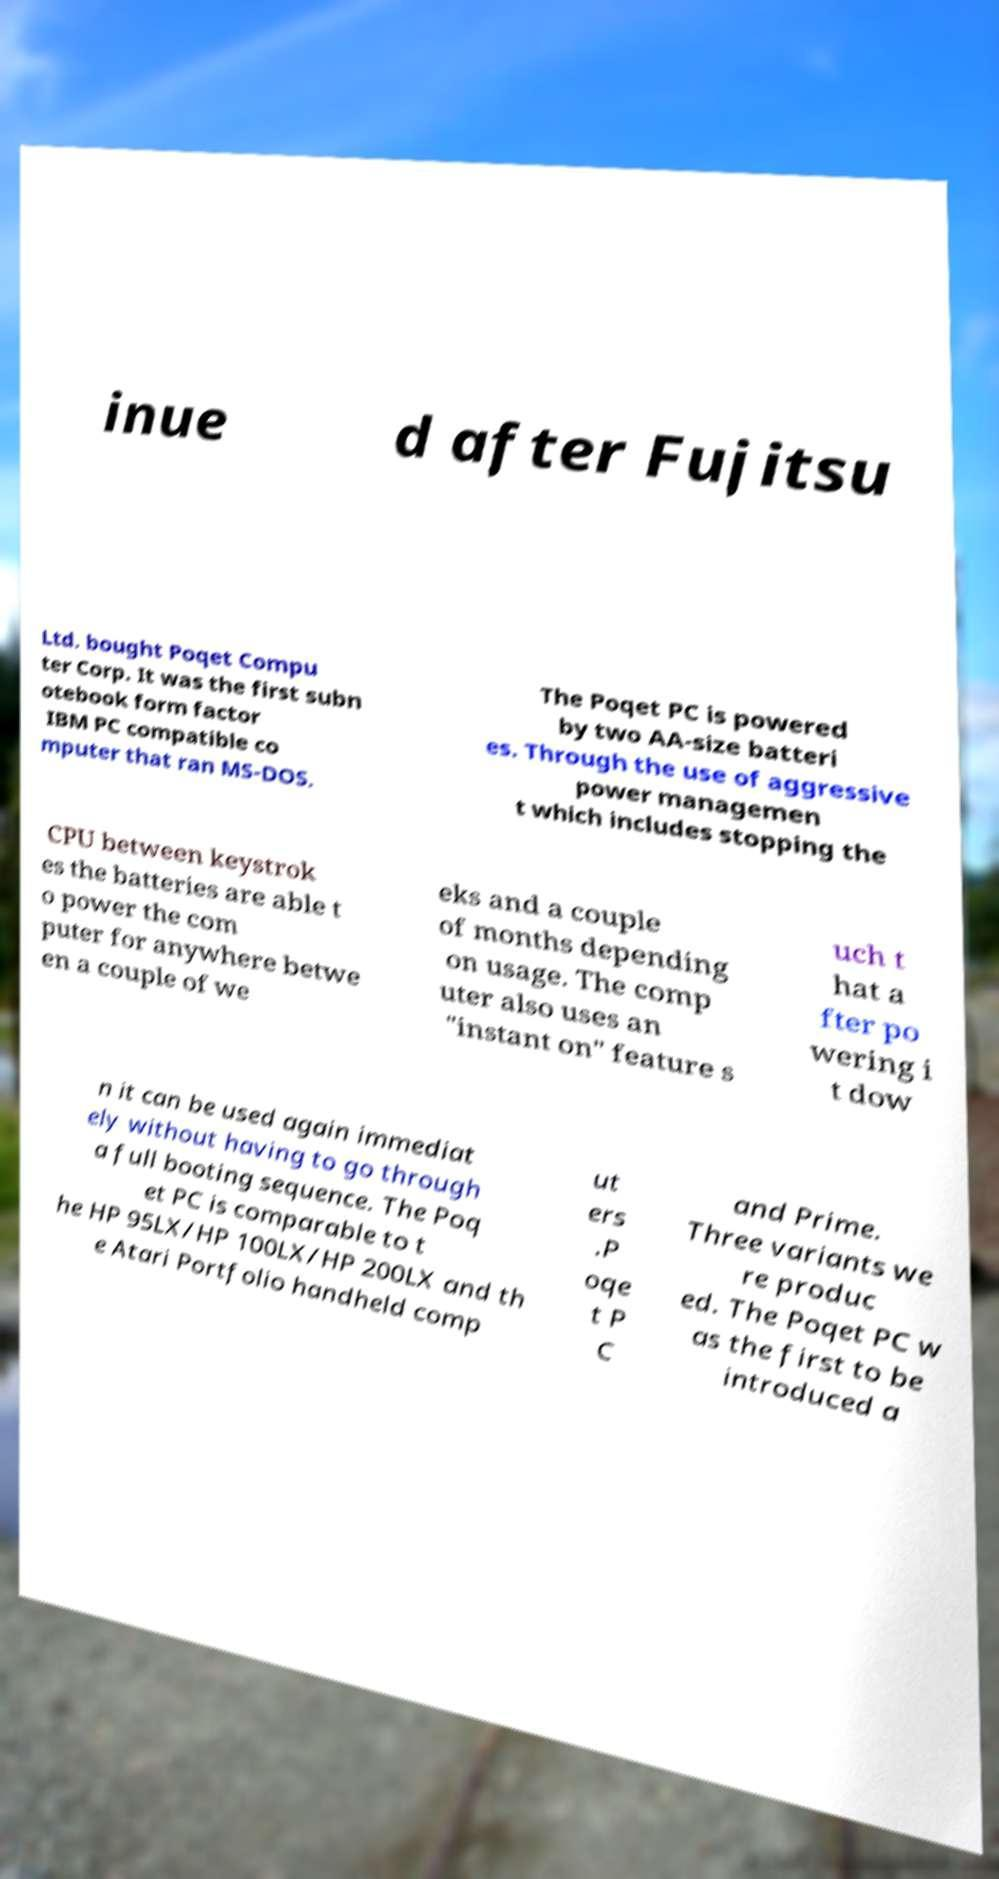I need the written content from this picture converted into text. Can you do that? inue d after Fujitsu Ltd. bought Poqet Compu ter Corp. It was the first subn otebook form factor IBM PC compatible co mputer that ran MS-DOS. The Poqet PC is powered by two AA-size batteri es. Through the use of aggressive power managemen t which includes stopping the CPU between keystrok es the batteries are able t o power the com puter for anywhere betwe en a couple of we eks and a couple of months depending on usage. The comp uter also uses an "instant on" feature s uch t hat a fter po wering i t dow n it can be used again immediat ely without having to go through a full booting sequence. The Poq et PC is comparable to t he HP 95LX/HP 100LX/HP 200LX and th e Atari Portfolio handheld comp ut ers .P oqe t P C and Prime. Three variants we re produc ed. The Poqet PC w as the first to be introduced a 